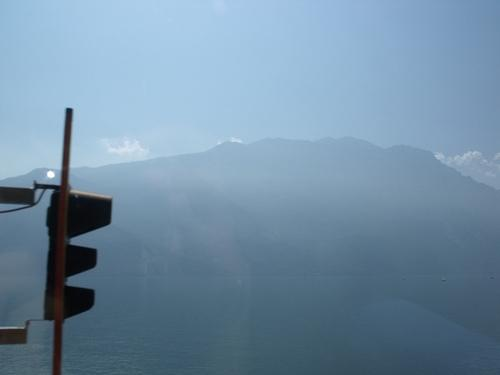Briefly describe the area above the mountain in the image. Above the mountain, there is a blue sky with some white clouds. List three objects found in the image and their respective sizes. White cloud in the sky with size 53x53, mountain with size 238x238, and traffic light on pole with size 55x55. Describe the relationship between the main subject and its environment. The mountain is surrounded by small hills, blue sky with white clouds, and blue water that reflects sunlight. What is the tone or mood of the image based on the scenery? The image has a calm and serene mood with clouds, mountains, and blue water. What are the colors mentioned in the image's objects? White, blue, and brown are mentioned in the objects' descriptions. Summarize the image's most prominent features. There are mountains, small hills, a blue sky with white clouds, traffic lights, and reflections of sunlight on blue water. What is the image's primary element related to weather? The sky is blue and clear with white clouds. Count and name the distinct types of objects mentioned in the image. 9 distinct objects: white cloud, traffic light, small hill, mountain, traffic signals, pole, sunlight, reflection, and water. Mention something that's happening in the image related to sunlight. Sunlight is hitting the mountain, and there is a reflection of the sun on the water. 